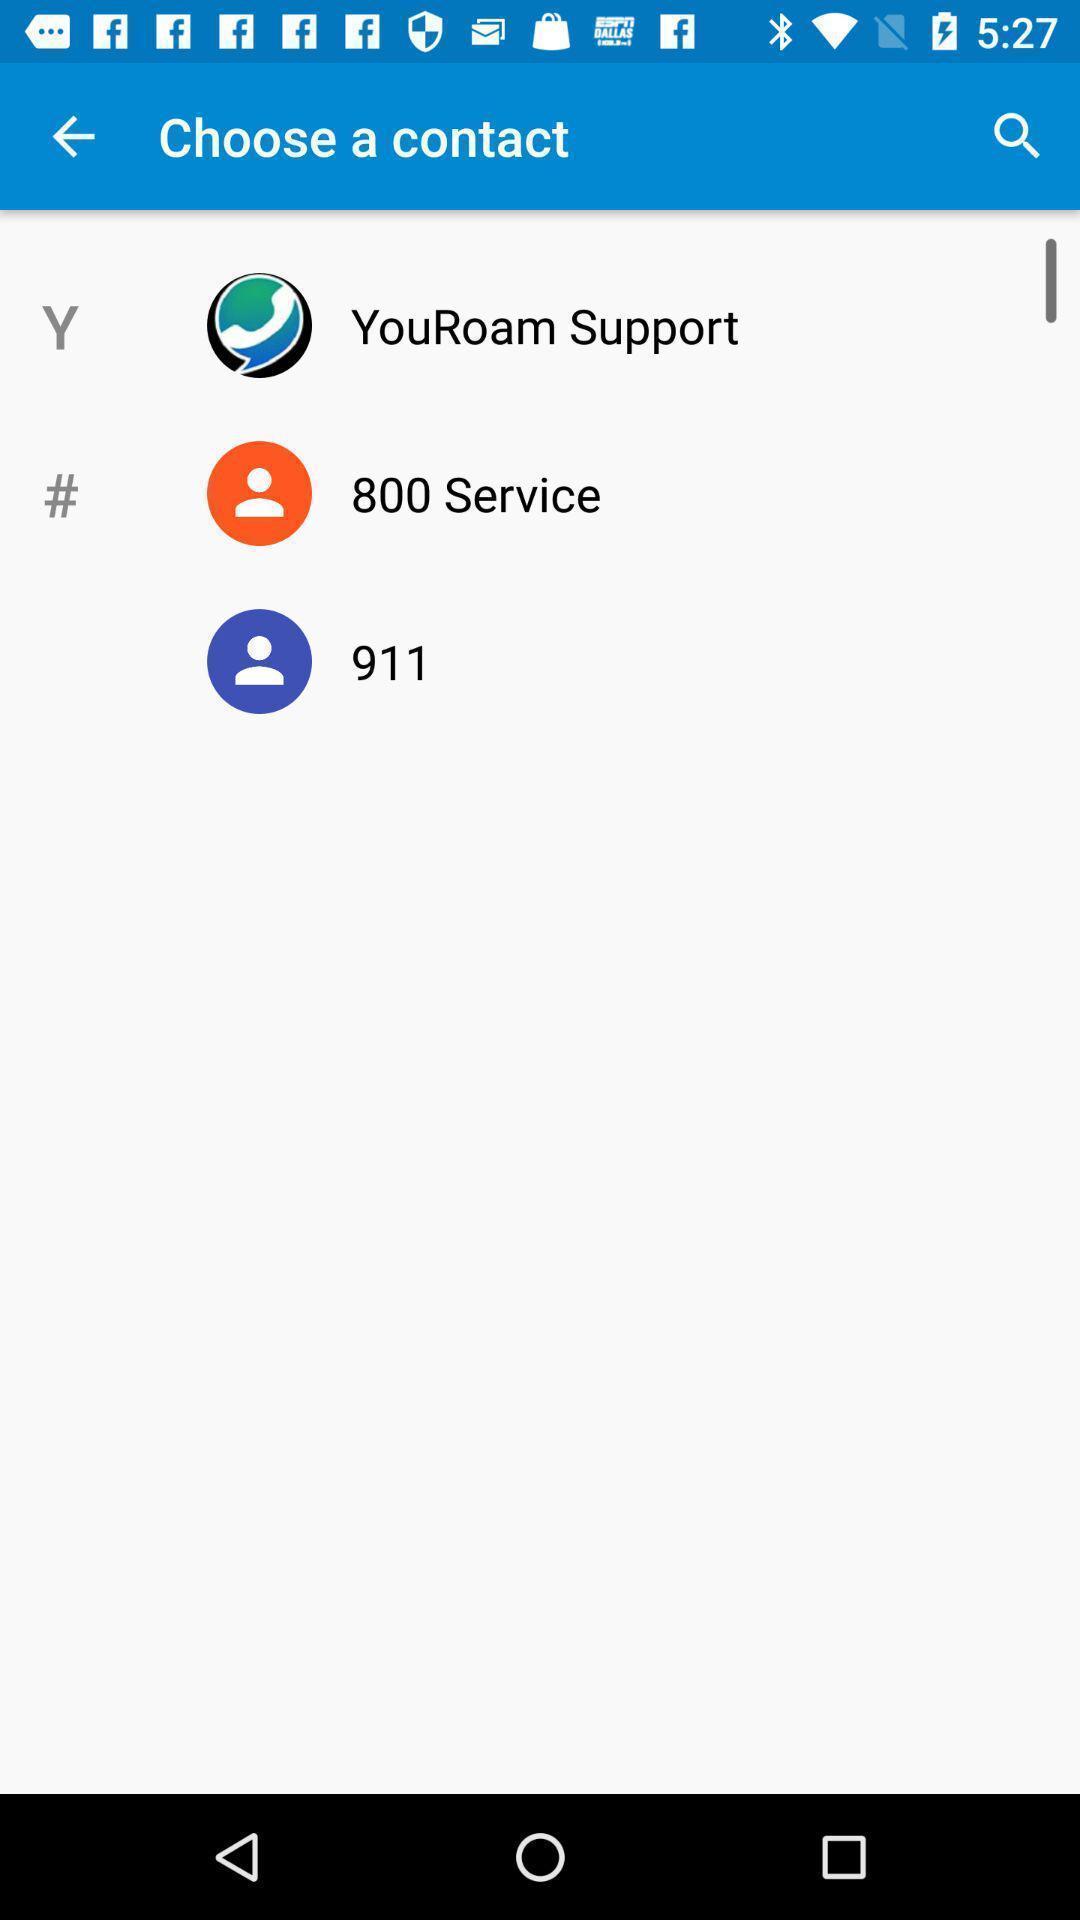Tell me what you see in this picture. Page showing choose a contact. 